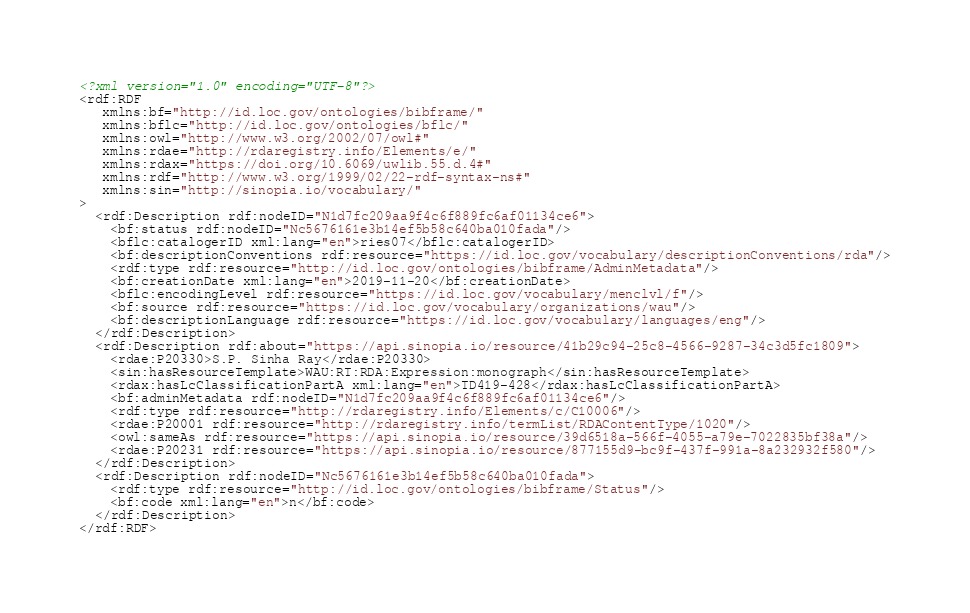<code> <loc_0><loc_0><loc_500><loc_500><_XML_><?xml version="1.0" encoding="UTF-8"?>
<rdf:RDF
   xmlns:bf="http://id.loc.gov/ontologies/bibframe/"
   xmlns:bflc="http://id.loc.gov/ontologies/bflc/"
   xmlns:owl="http://www.w3.org/2002/07/owl#"
   xmlns:rdae="http://rdaregistry.info/Elements/e/"
   xmlns:rdax="https://doi.org/10.6069/uwlib.55.d.4#"
   xmlns:rdf="http://www.w3.org/1999/02/22-rdf-syntax-ns#"
   xmlns:sin="http://sinopia.io/vocabulary/"
>
  <rdf:Description rdf:nodeID="N1d7fc209aa9f4c6f889fc6af01134ce6">
    <bf:status rdf:nodeID="Nc5676161e3b14ef5b58c640ba010fada"/>
    <bflc:catalogerID xml:lang="en">ries07</bflc:catalogerID>
    <bf:descriptionConventions rdf:resource="https://id.loc.gov/vocabulary/descriptionConventions/rda"/>
    <rdf:type rdf:resource="http://id.loc.gov/ontologies/bibframe/AdminMetadata"/>
    <bf:creationDate xml:lang="en">2019-11-20</bf:creationDate>
    <bflc:encodingLevel rdf:resource="https://id.loc.gov/vocabulary/menclvl/f"/>
    <bf:source rdf:resource="https://id.loc.gov/vocabulary/organizations/wau"/>
    <bf:descriptionLanguage rdf:resource="https://id.loc.gov/vocabulary/languages/eng"/>
  </rdf:Description>
  <rdf:Description rdf:about="https://api.sinopia.io/resource/41b29c94-25c8-4566-9287-34c3d5fc1809">
    <rdae:P20330>S.P. Sinha Ray</rdae:P20330>
    <sin:hasResourceTemplate>WAU:RT:RDA:Expression:monograph</sin:hasResourceTemplate>
    <rdax:hasLcClassificationPartA xml:lang="en">TD419-428</rdax:hasLcClassificationPartA>
    <bf:adminMetadata rdf:nodeID="N1d7fc209aa9f4c6f889fc6af01134ce6"/>
    <rdf:type rdf:resource="http://rdaregistry.info/Elements/c/C10006"/>
    <rdae:P20001 rdf:resource="http://rdaregistry.info/termList/RDAContentType/1020"/>
    <owl:sameAs rdf:resource="https://api.sinopia.io/resource/39d6518a-566f-4055-a79e-7022835bf38a"/>
    <rdae:P20231 rdf:resource="https://api.sinopia.io/resource/877155d9-bc9f-437f-991a-8a232932f580"/>
  </rdf:Description>
  <rdf:Description rdf:nodeID="Nc5676161e3b14ef5b58c640ba010fada">
    <rdf:type rdf:resource="http://id.loc.gov/ontologies/bibframe/Status"/>
    <bf:code xml:lang="en">n</bf:code>
  </rdf:Description>
</rdf:RDF>
</code> 